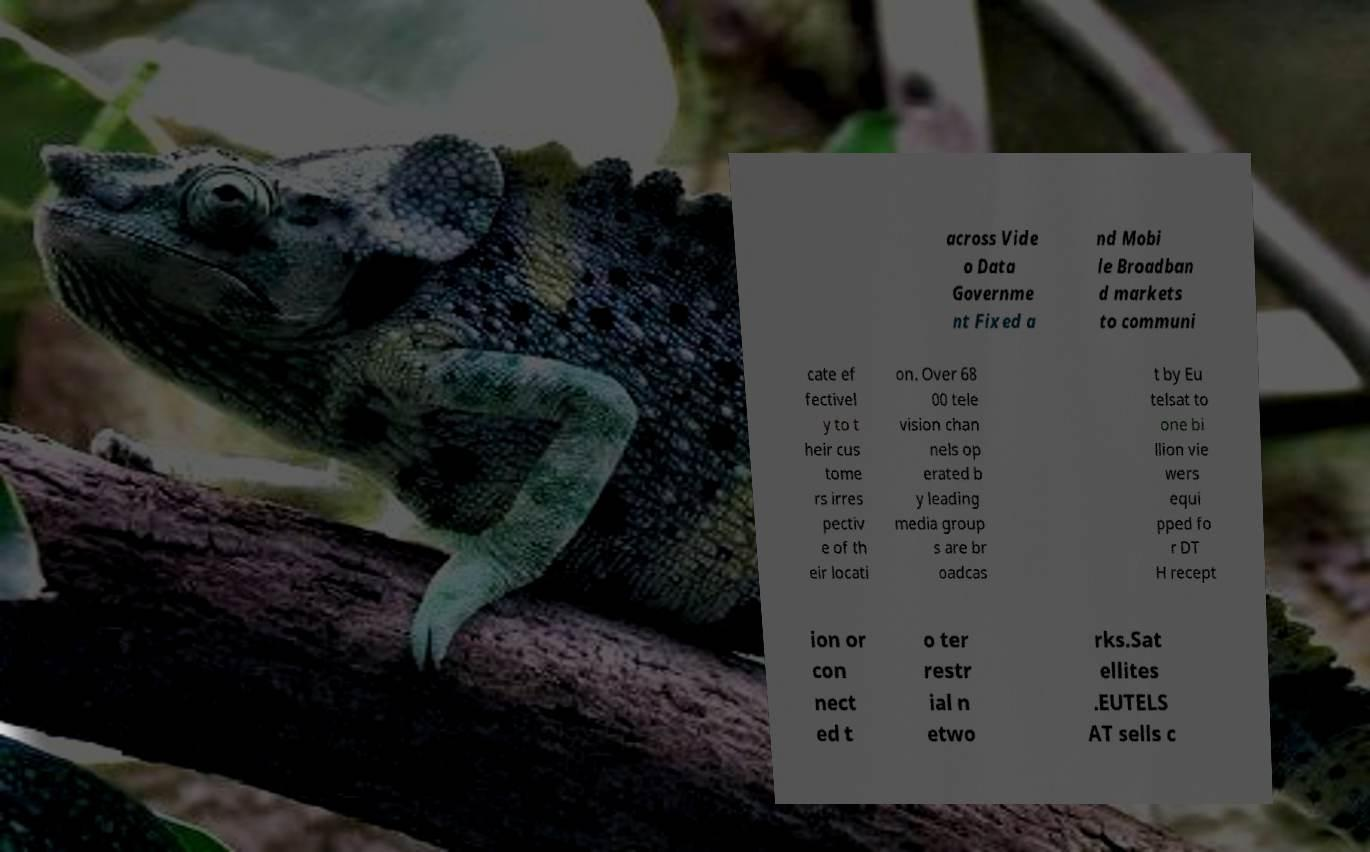Can you read and provide the text displayed in the image?This photo seems to have some interesting text. Can you extract and type it out for me? across Vide o Data Governme nt Fixed a nd Mobi le Broadban d markets to communi cate ef fectivel y to t heir cus tome rs irres pectiv e of th eir locati on. Over 68 00 tele vision chan nels op erated b y leading media group s are br oadcas t by Eu telsat to one bi llion vie wers equi pped fo r DT H recept ion or con nect ed t o ter restr ial n etwo rks.Sat ellites .EUTELS AT sells c 